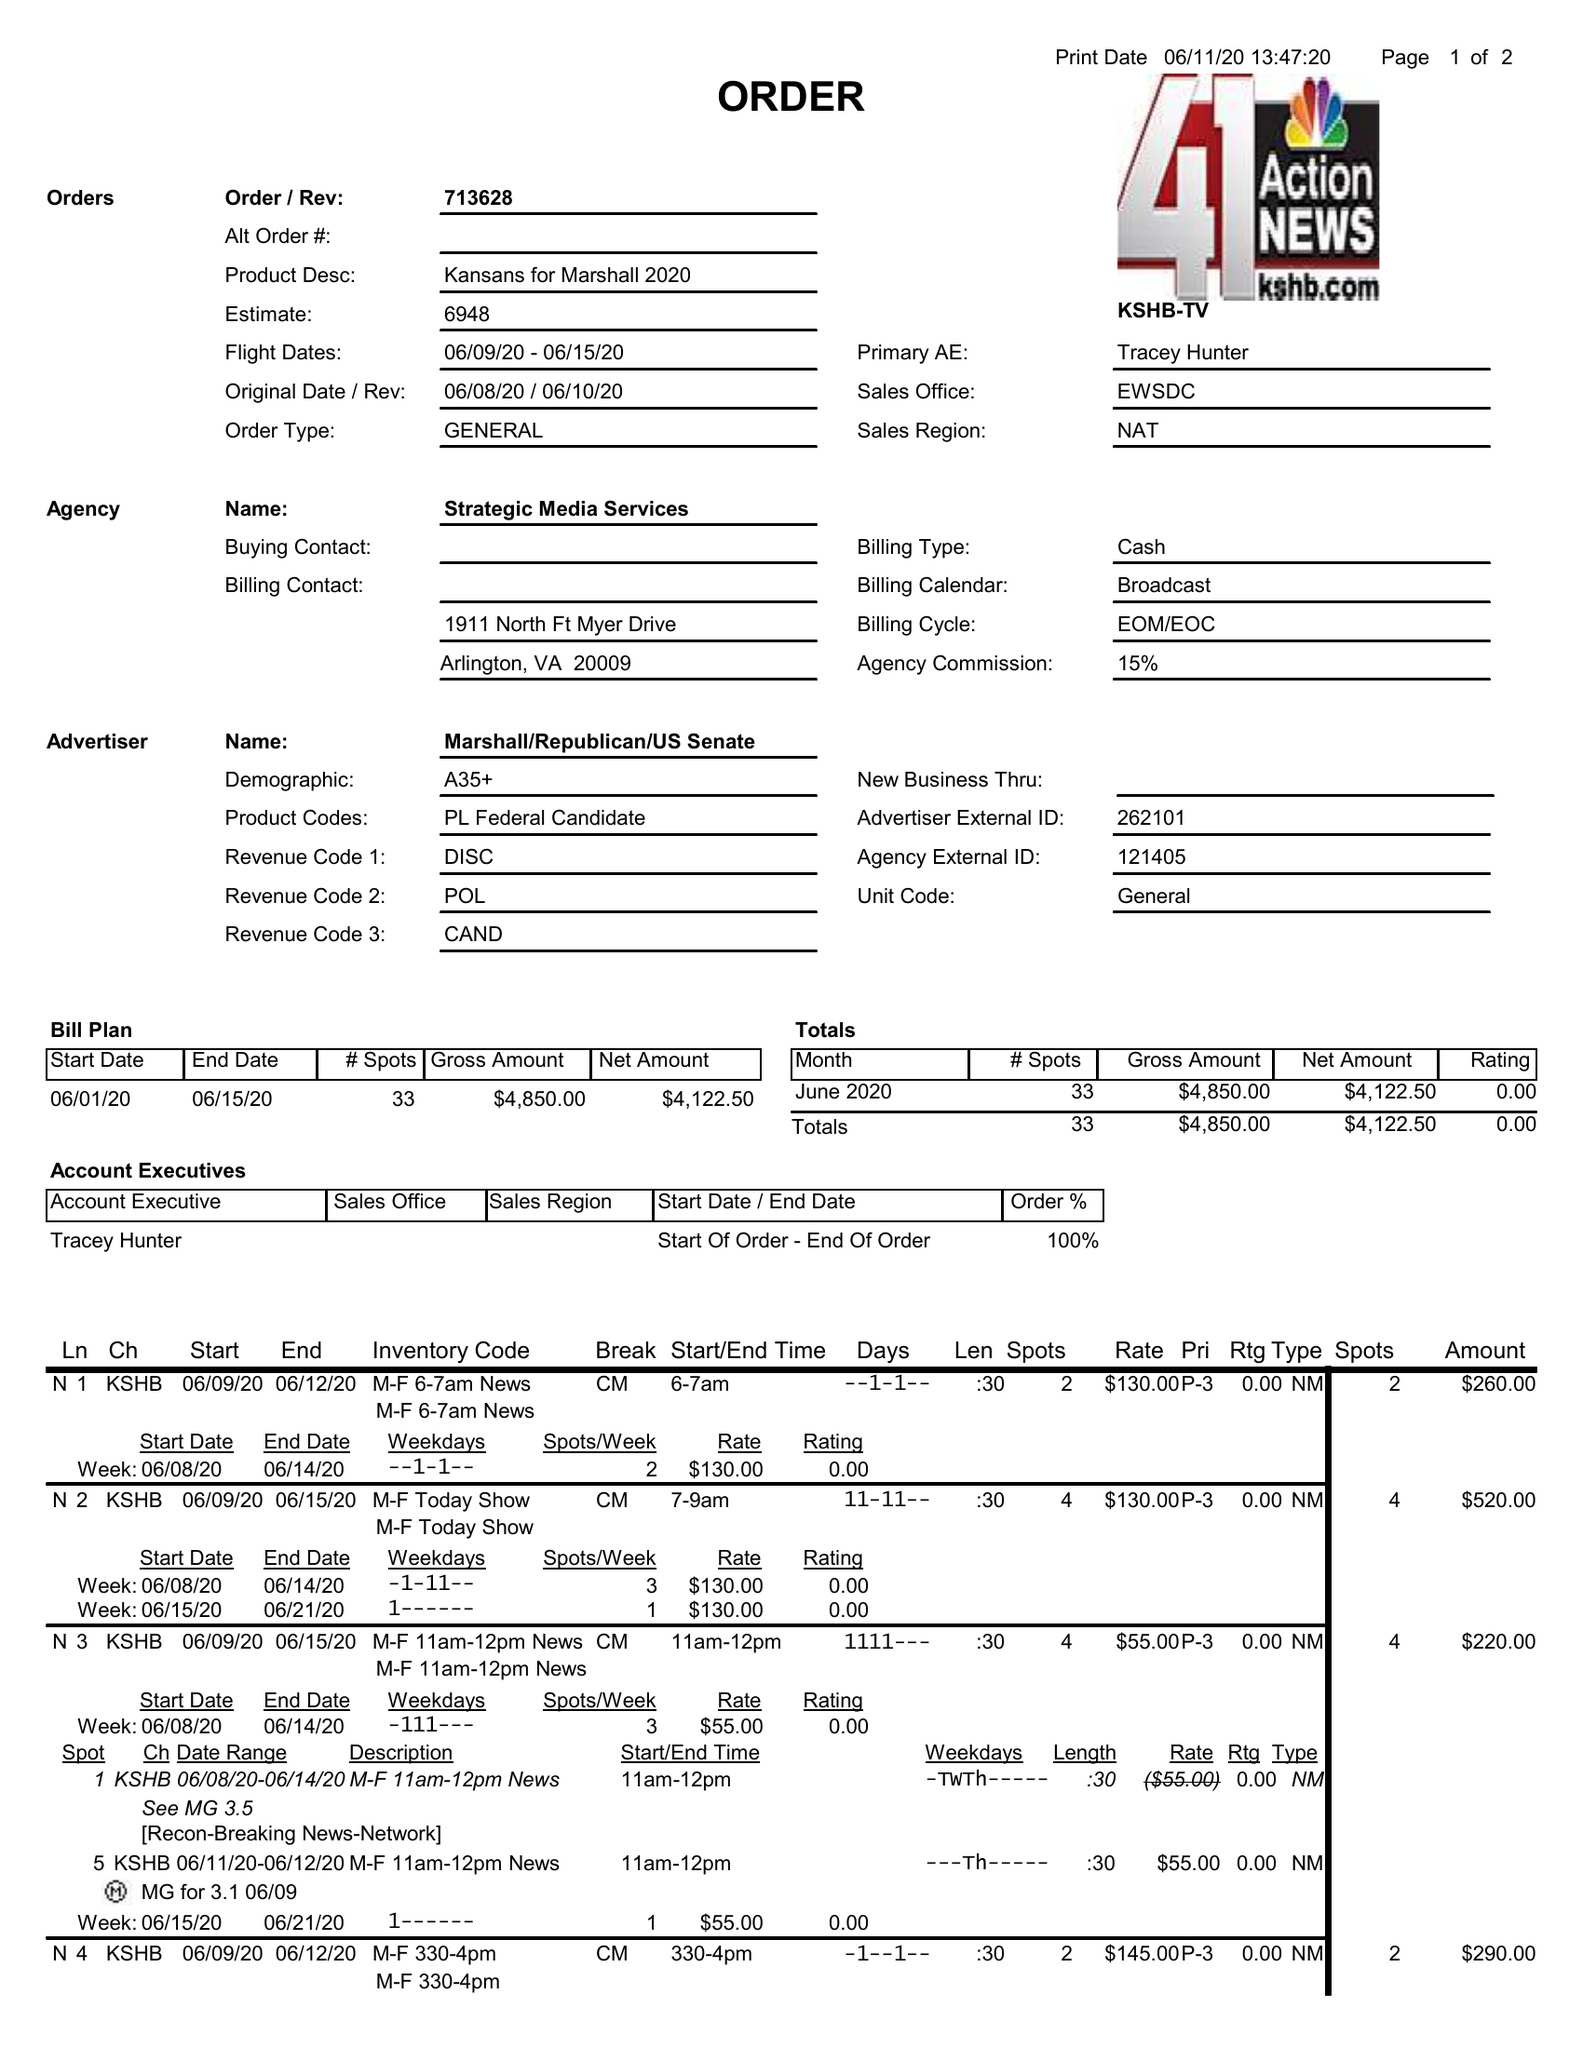What is the value for the gross_amount?
Answer the question using a single word or phrase. 4850.00 